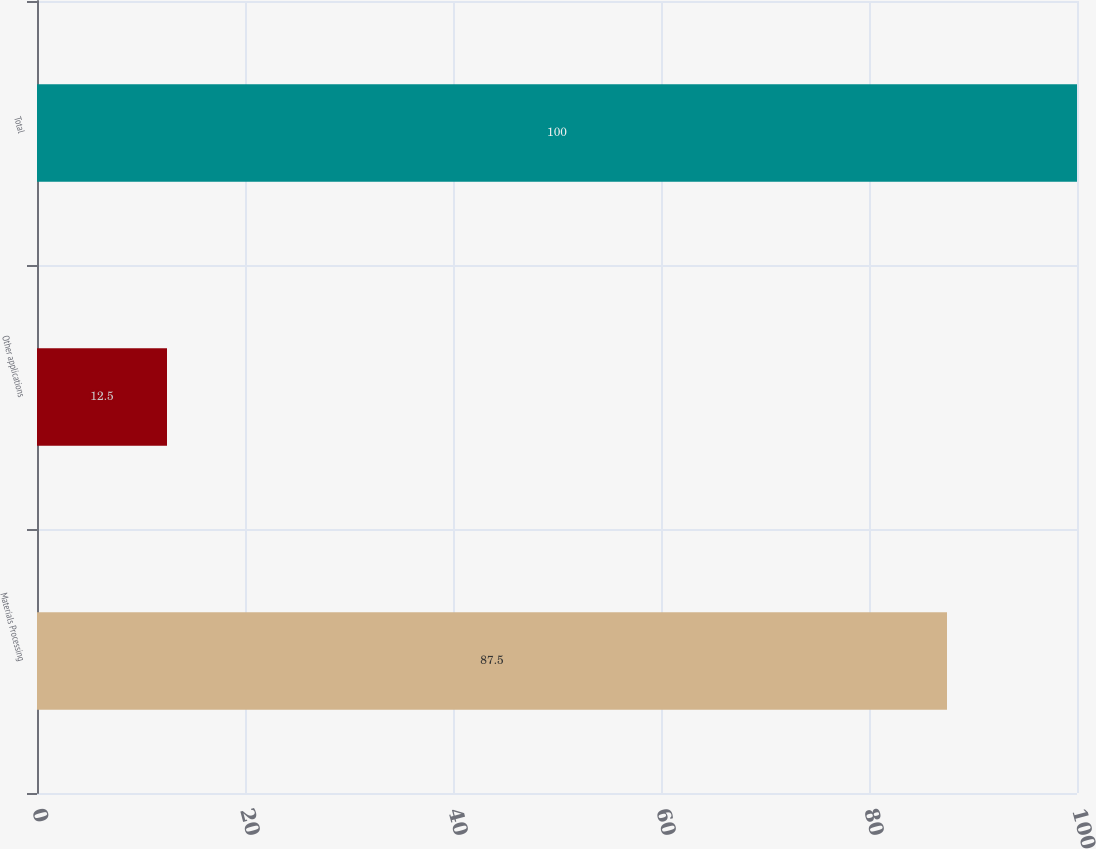Convert chart. <chart><loc_0><loc_0><loc_500><loc_500><bar_chart><fcel>Materials Processing<fcel>Other applications<fcel>Total<nl><fcel>87.5<fcel>12.5<fcel>100<nl></chart> 